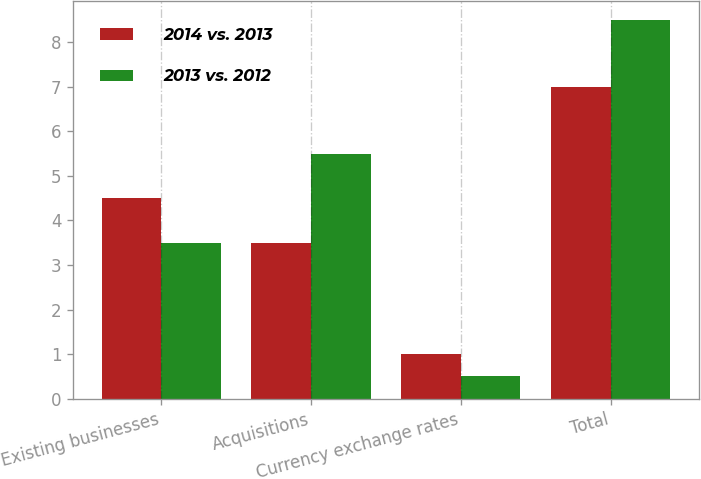Convert chart. <chart><loc_0><loc_0><loc_500><loc_500><stacked_bar_chart><ecel><fcel>Existing businesses<fcel>Acquisitions<fcel>Currency exchange rates<fcel>Total<nl><fcel>2014 vs. 2013<fcel>4.5<fcel>3.5<fcel>1<fcel>7<nl><fcel>2013 vs. 2012<fcel>3.5<fcel>5.5<fcel>0.5<fcel>8.5<nl></chart> 